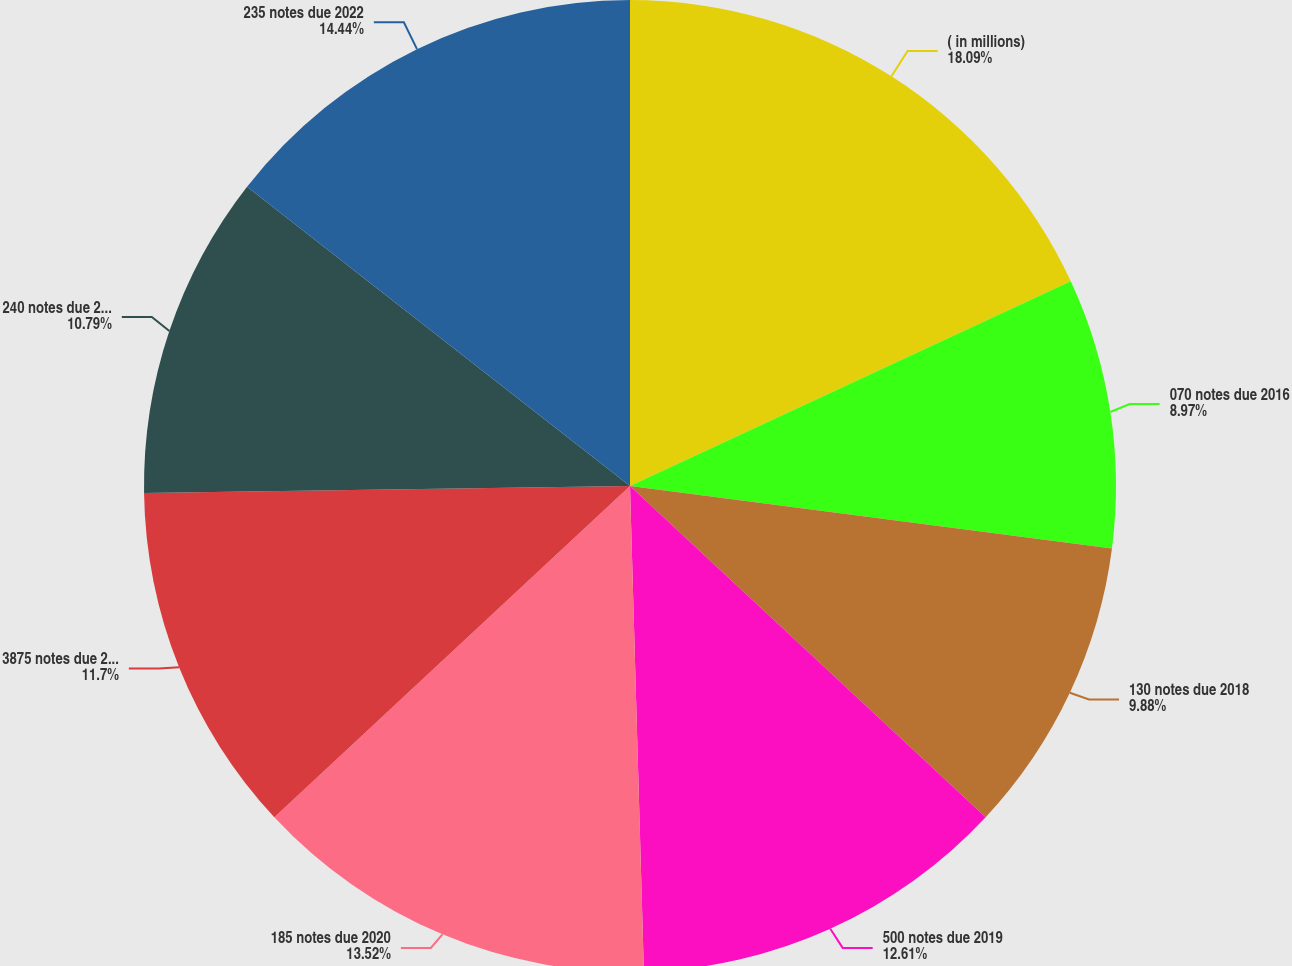Convert chart. <chart><loc_0><loc_0><loc_500><loc_500><pie_chart><fcel>( in millions)<fcel>070 notes due 2016<fcel>130 notes due 2018<fcel>500 notes due 2019<fcel>185 notes due 2020<fcel>3875 notes due 2021<fcel>240 notes due 2022<fcel>235 notes due 2022<nl><fcel>18.08%<fcel>8.97%<fcel>9.88%<fcel>12.61%<fcel>13.52%<fcel>11.7%<fcel>10.79%<fcel>14.44%<nl></chart> 